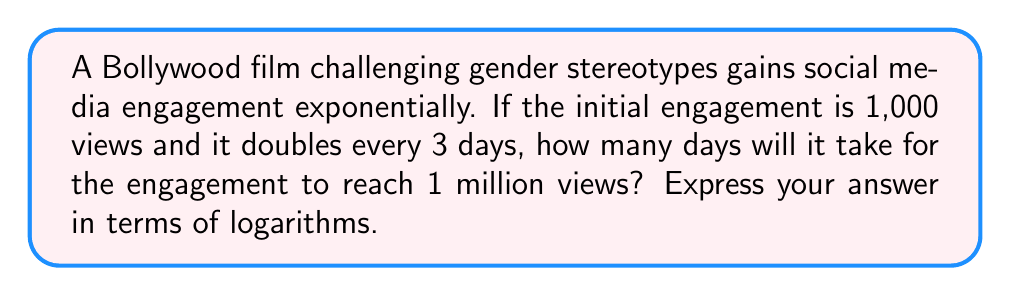Teach me how to tackle this problem. Let's approach this step-by-step:

1) We start with 1,000 views and want to reach 1,000,000 views.

2) The engagement doubles every 3 days. Let's express this as a function of time (in days):
   $f(t) = 1000 \cdot 2^{\frac{t}{3}}$

3) We want to find $t$ when $f(t) = 1,000,000$:
   $1000 \cdot 2^{\frac{t}{3}} = 1,000,000$

4) Divide both sides by 1000:
   $2^{\frac{t}{3}} = 1,000$

5) Take the logarithm (base 2) of both sides:
   $\log_2(2^{\frac{t}{3}}) = \log_2(1,000)$

6) Simplify the left side using logarithm properties:
   $\frac{t}{3} = \log_2(1,000)$

7) Multiply both sides by 3:
   $t = 3 \cdot \log_2(1,000)$

8) We can leave the answer in this logarithmic form, or we can calculate it:
   $t = 3 \cdot \log_2(1,000) \approx 29.897$ days

Therefore, it will take approximately 30 days for the engagement to reach 1 million views.
Answer: $3 \cdot \log_2(1,000)$ days 